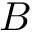<formula> <loc_0><loc_0><loc_500><loc_500>B</formula> 